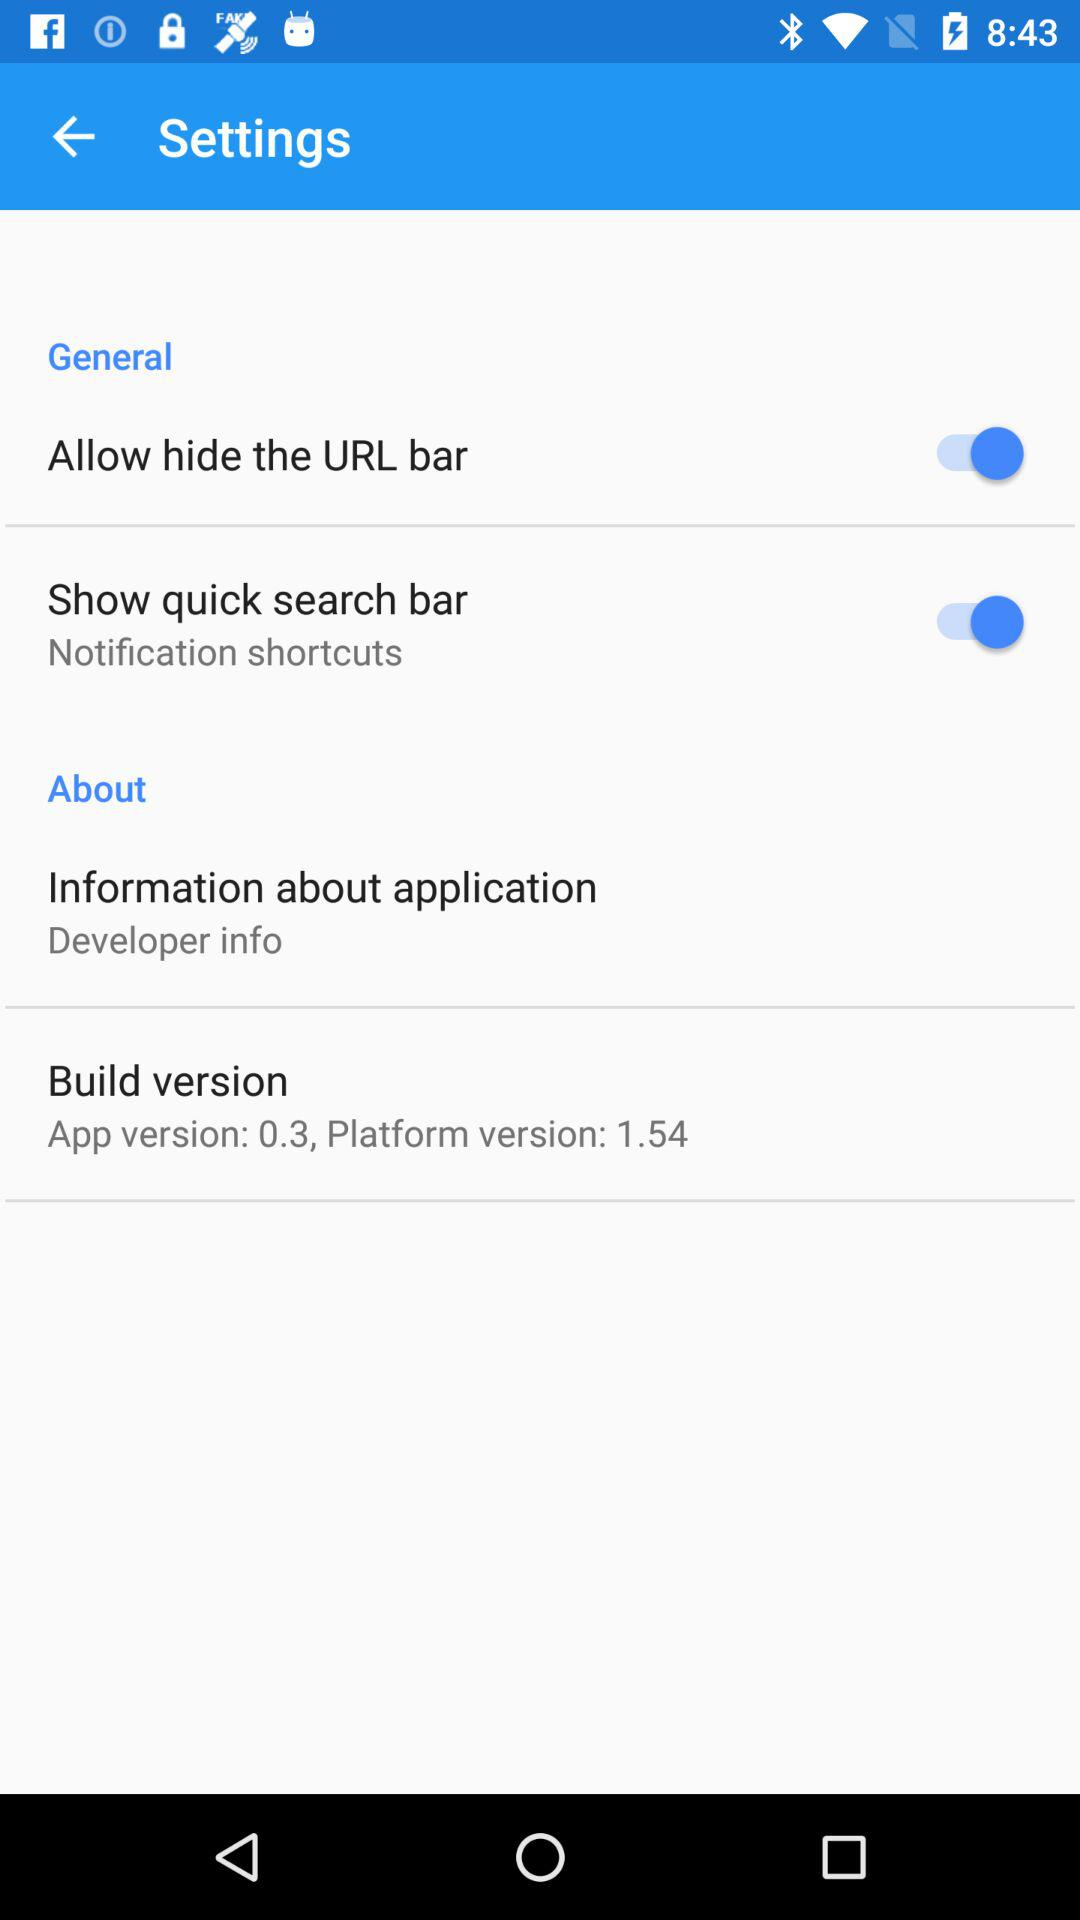What app version is shown? The shown app version is 0.3. 